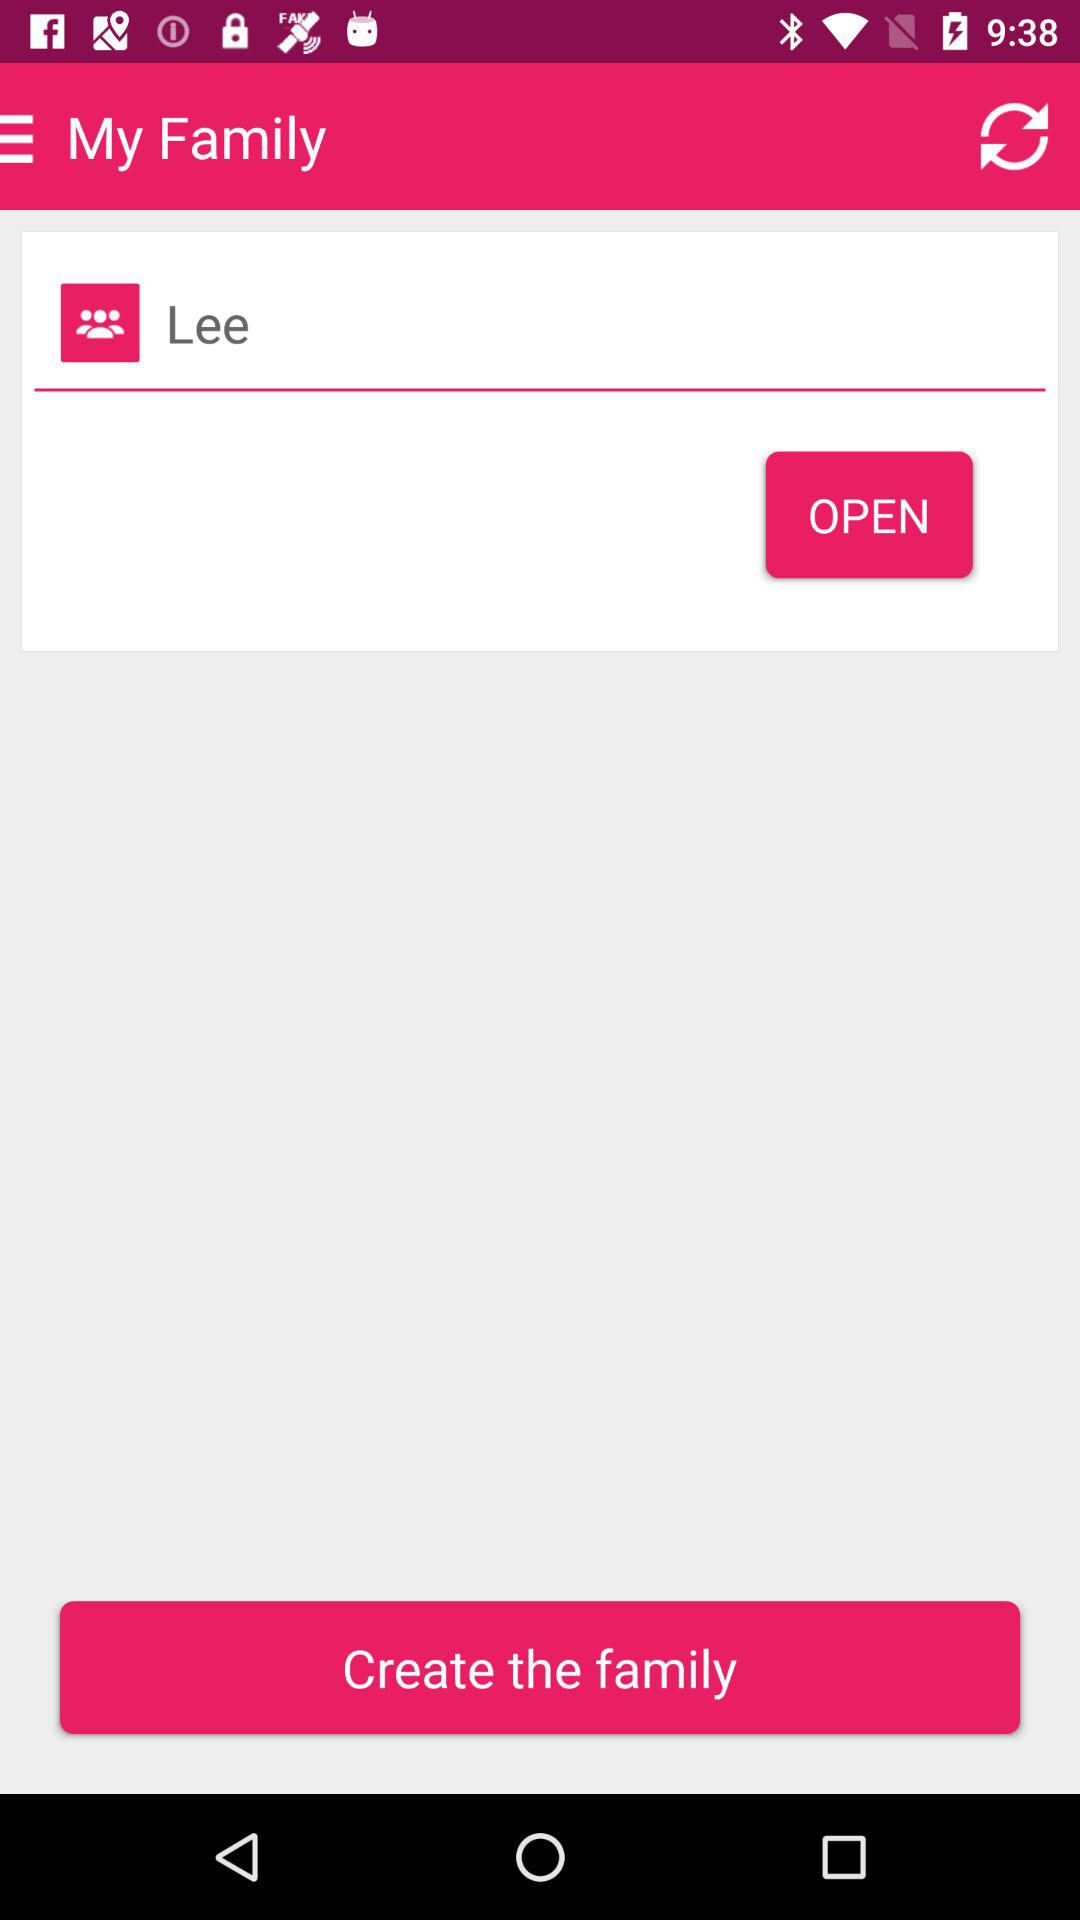What is the application name? The application name is "My Family". 